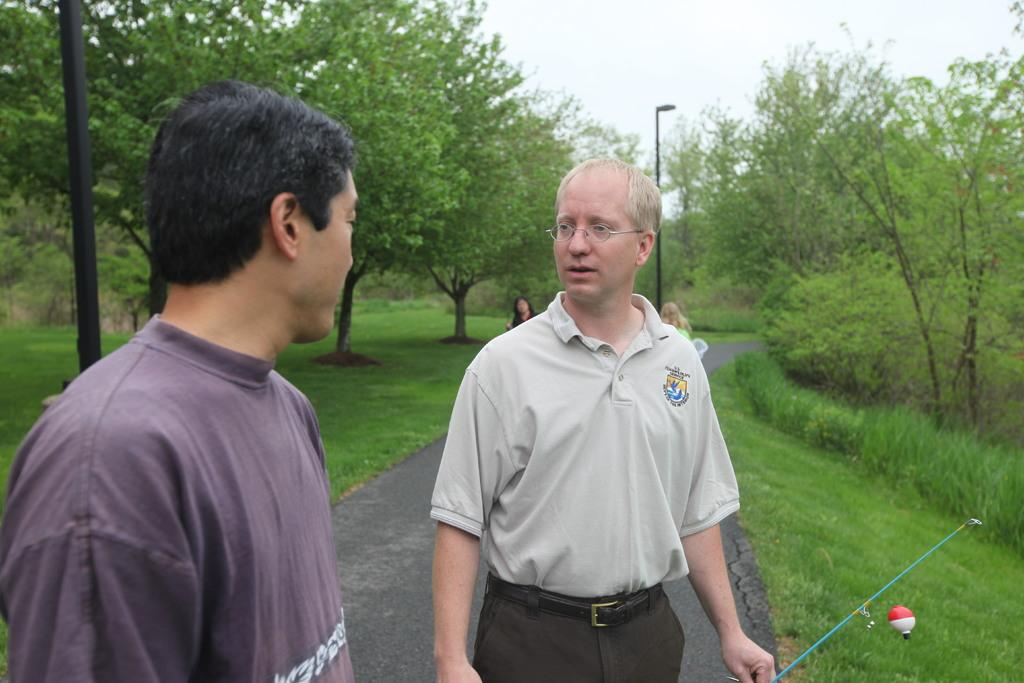What is happening in the middle of the image? There are people standing in the middle of the image. What can be seen behind the people? There are poles behind the people. What type of natural environment is visible in the background? There are trees, grass, and the sky visible in the background. What color is the paint on the dinosaurs in the image? There are no dinosaurs present in the image, so there is no paint to describe. 